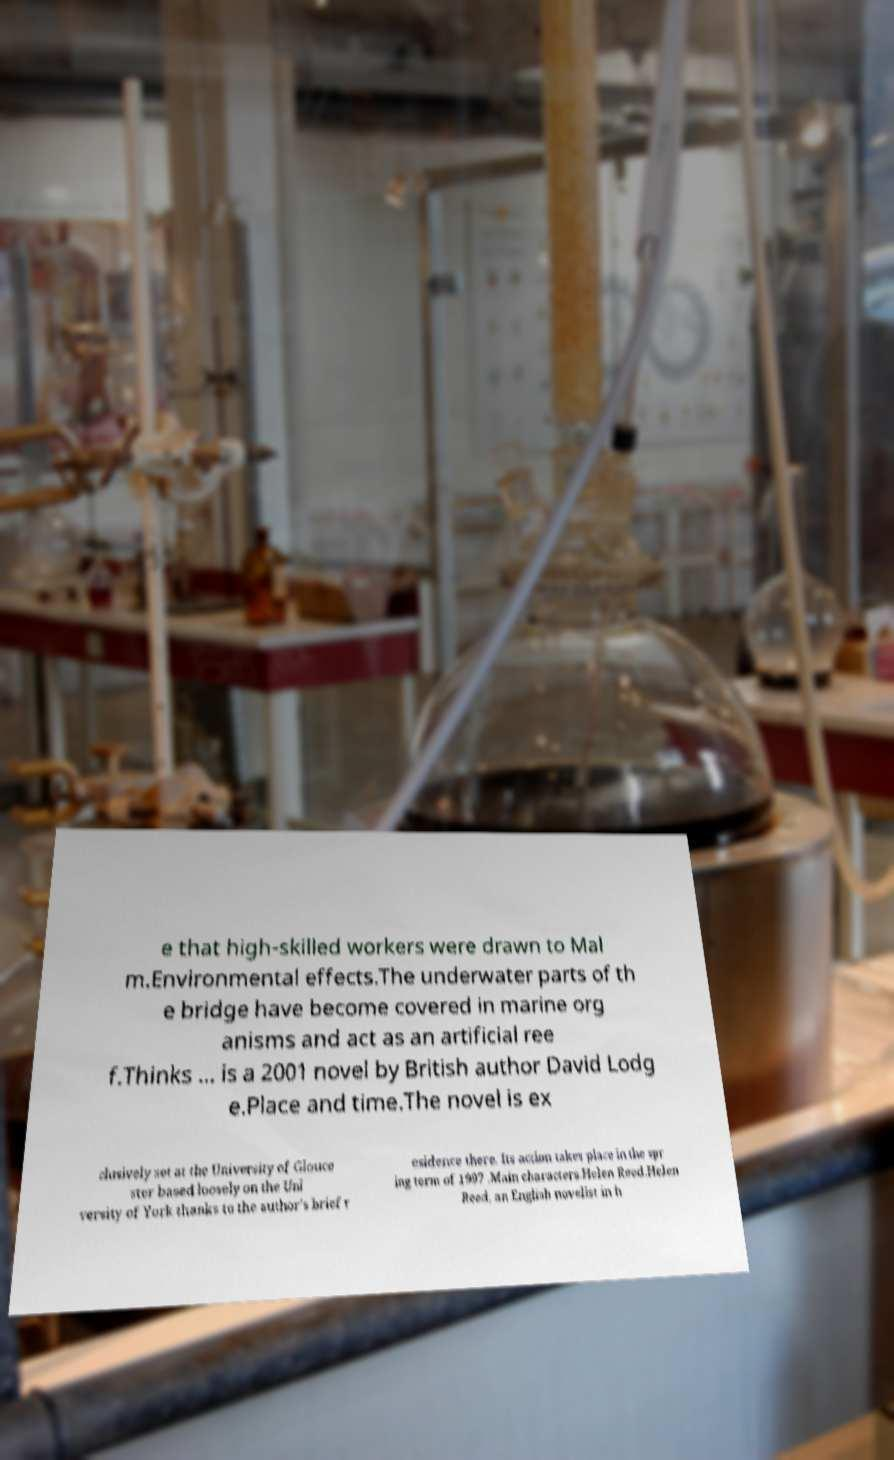Could you extract and type out the text from this image? e that high-skilled workers were drawn to Mal m.Environmental effects.The underwater parts of th e bridge have become covered in marine org anisms and act as an artificial ree f.Thinks ... is a 2001 novel by British author David Lodg e.Place and time.The novel is ex clusively set at the University of Glouce ster based loosely on the Uni versity of York thanks to the author's brief r esidence there. Its action takes place in the spr ing term of 1997 .Main characters.Helen Reed.Helen Reed, an English novelist in h 